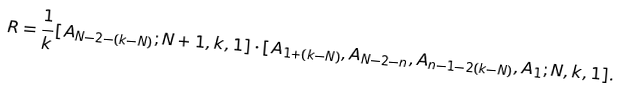<formula> <loc_0><loc_0><loc_500><loc_500>R = \frac { 1 } { k } [ A _ { N - 2 - ( k - N ) } ; N + 1 , k , 1 ] \cdot [ A _ { 1 + ( k - N ) } , A _ { N - 2 - n } , A _ { n - 1 - 2 ( k - N ) } , A _ { 1 } ; N , k , 1 ] .</formula> 